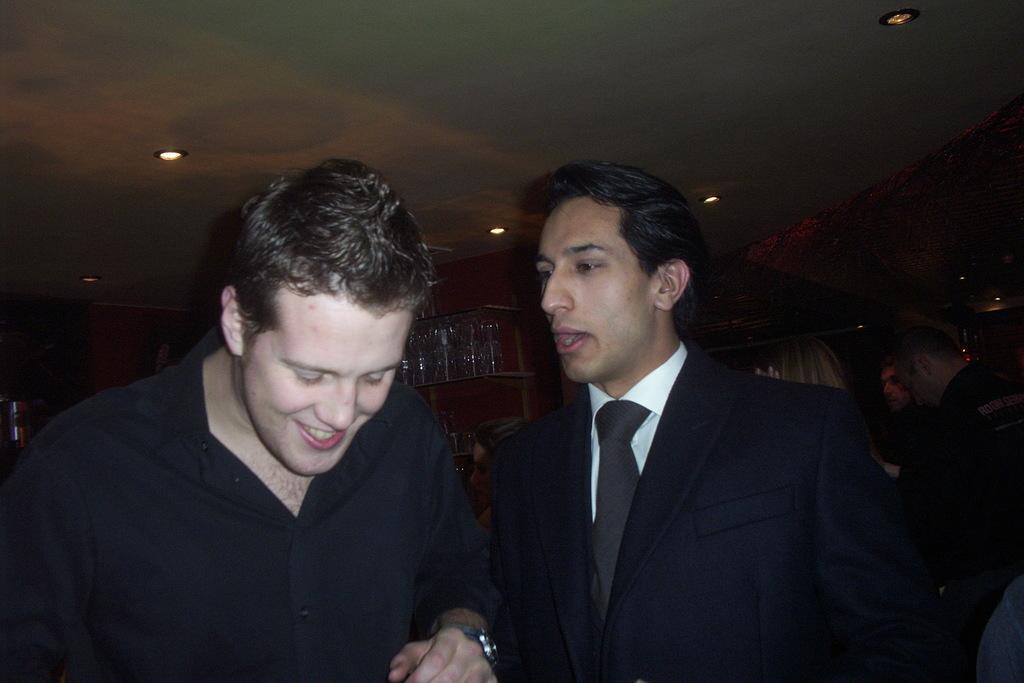Can you describe this image briefly? In this picture we can see a group of people standing on the floor and a man in the black shirt is smiling. Behind the man there are glasses in the rack. At the top there are ceiling lights. 